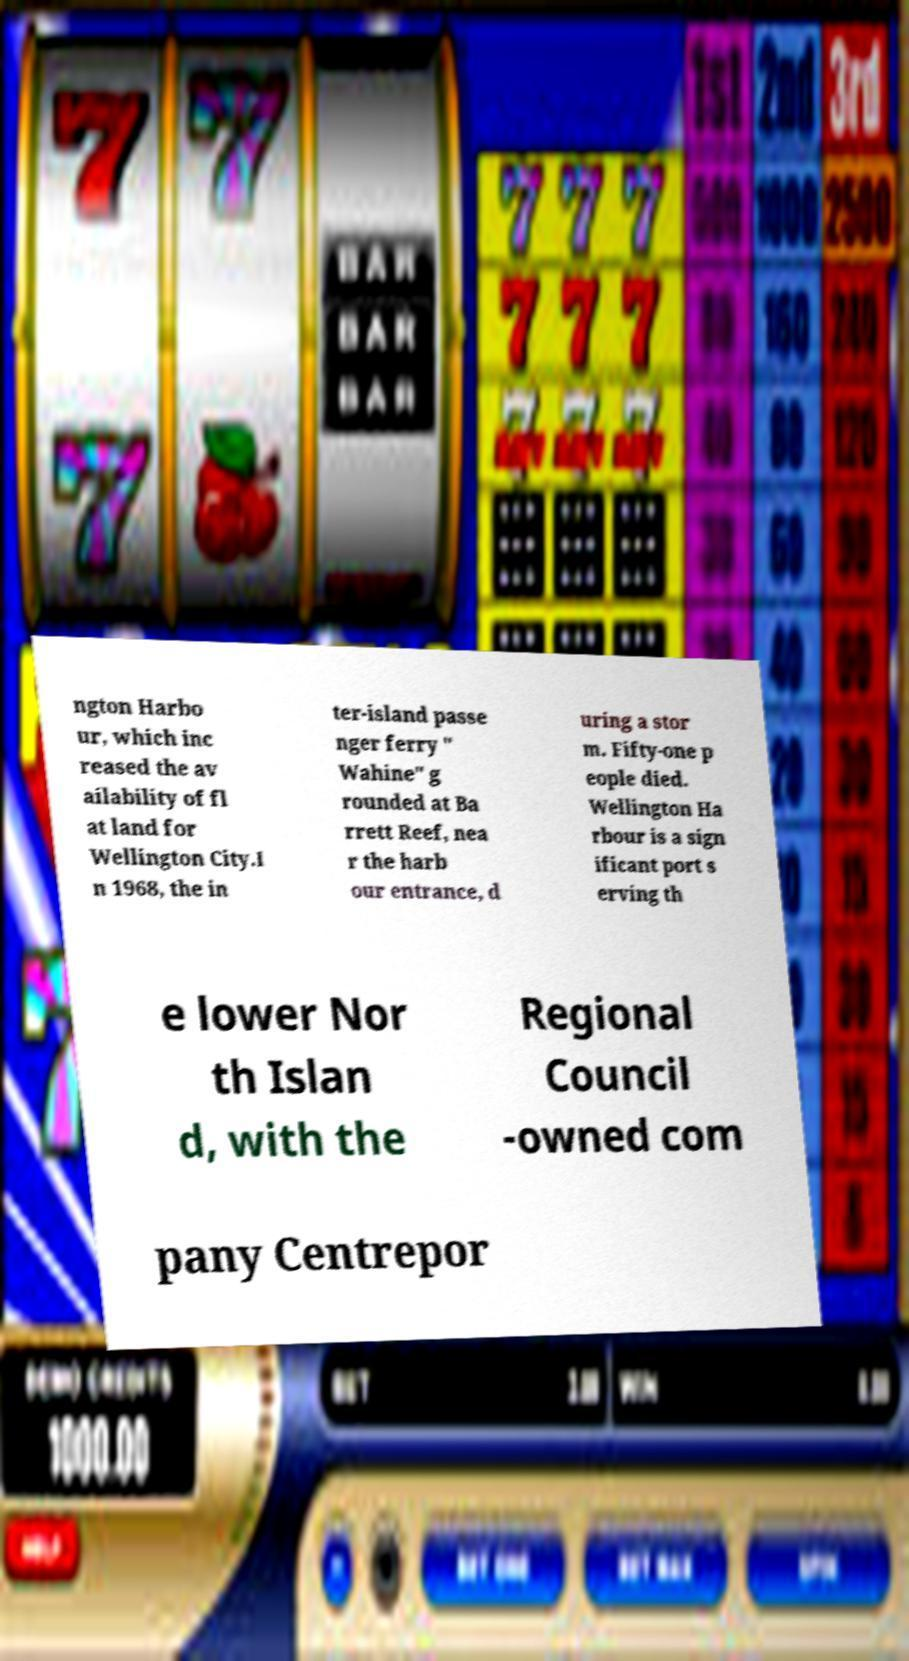Can you read and provide the text displayed in the image?This photo seems to have some interesting text. Can you extract and type it out for me? ngton Harbo ur, which inc reased the av ailability of fl at land for Wellington City.I n 1968, the in ter-island passe nger ferry " Wahine" g rounded at Ba rrett Reef, nea r the harb our entrance, d uring a stor m. Fifty-one p eople died. Wellington Ha rbour is a sign ificant port s erving th e lower Nor th Islan d, with the Regional Council -owned com pany Centrepor 